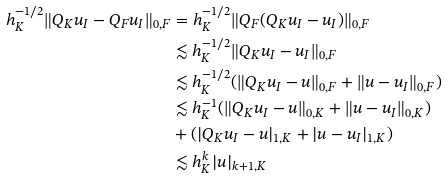Convert formula to latex. <formula><loc_0><loc_0><loc_500><loc_500>h _ { K } ^ { - 1 / 2 } \| Q _ { K } u _ { I } - Q _ { F } u _ { I } \| _ { 0 , F } & = h _ { K } ^ { - 1 / 2 } \| Q _ { F } ( Q _ { K } u _ { I } - u _ { I } ) \| _ { 0 , F } \\ & \lesssim h _ { K } ^ { - 1 / 2 } \| Q _ { K } u _ { I } - u _ { I } \| _ { 0 , F } \\ & \lesssim h _ { K } ^ { - 1 / 2 } ( \| Q _ { K } u _ { I } - u \| _ { 0 , F } + \| u - u _ { I } \| _ { 0 , F } ) \\ & \lesssim h _ { K } ^ { - 1 } ( \| Q _ { K } u _ { I } - u \| _ { 0 , K } + \| u - u _ { I } \| _ { 0 , K } ) \\ & + ( | Q _ { K } u _ { I } - u | _ { 1 , K } + | u - u _ { I } | _ { 1 , K } ) \\ & \lesssim h _ { K } ^ { k } | u | _ { k + 1 , K }</formula> 